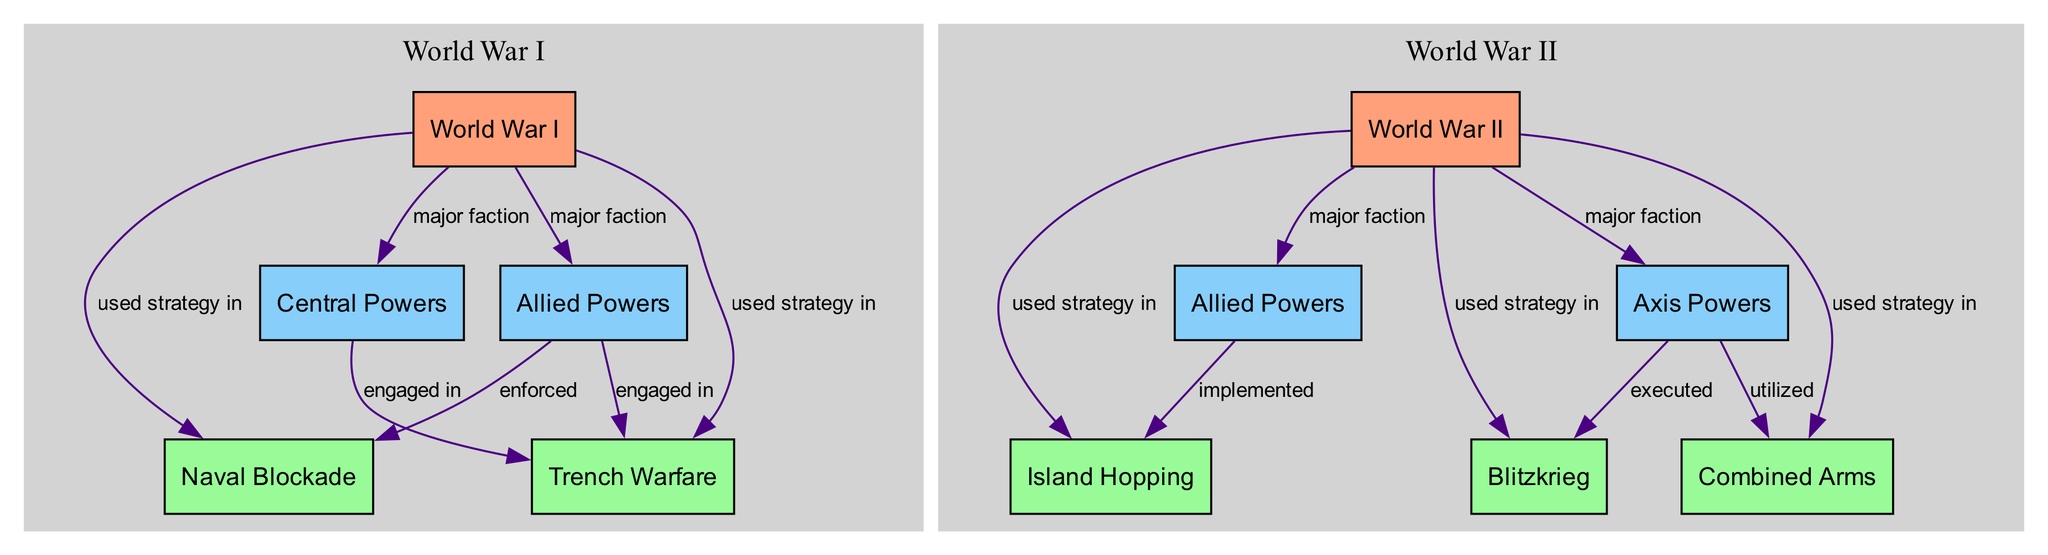What military strategy was primarily used in World War I? The diagram shows that "Trench Warfare" is a strategy linked directly to the "World War I" node, indicating it was primarily used during that conflict.
Answer: Trench Warfare How many major factions were involved in World War I? The diagram indicates two major factions connected to "World War I," which are the "Allied Powers" and the "Central Powers," hence counting them gives a total of two.
Answer: 2 Which strategy did the Axis Powers execute in World War II? Looking at the connections, the "Axis Powers" node links to "Blitzkrieg" with the label "executed," stating explicitly that it was the strategy they used during World War II.
Answer: Blitzkrieg What strategy was implemented by the Allied Powers in World War II? The "Allied Powers" node in "World War II" has a direct link to "Island Hopping," with the label "implemented," showing this was the chosen strategy of the Allies.
Answer: Island Hopping What type of military strategy was used during World War I and not during World War II? The flow from "World War I" includes "Trench Warfare" but not "Blitzkrieg," "Island Hopping," or "Combined Arms," indicating that Trench Warfare was unique to World War I.
Answer: Trench Warfare Which strategy involves a combination of multiple military units? The diagram specifies that "Combined Arms" is a strategy used in World War II, characterized by the integration of different military branches such as infantry, armor, and air support.
Answer: Combined Arms How many strategies are directly associated with World War II? By analyzing the edges leading from "World War II," we see connections to three strategies: "Blitzkrieg," "Island Hopping," and "Combined Arms," hence the total is three.
Answer: 3 Which strategy was enforced by the Allied Powers in World War I? The diagram denotes that "Naval Blockade" is connected to the "Allied Powers" node under "World War I" with the label "enforced," indicating its significance during that period.
Answer: Naval Blockade Which two strategies are linked to World War II? Looking at the edges from the "World War II" node, we can see three strategies listed: "Blitzkrieg," "Island Hopping," and "Combined Arms," but selecting two of these demonstrates their interlinking with WWII.
Answer: Blitzkrieg, Island Hopping 